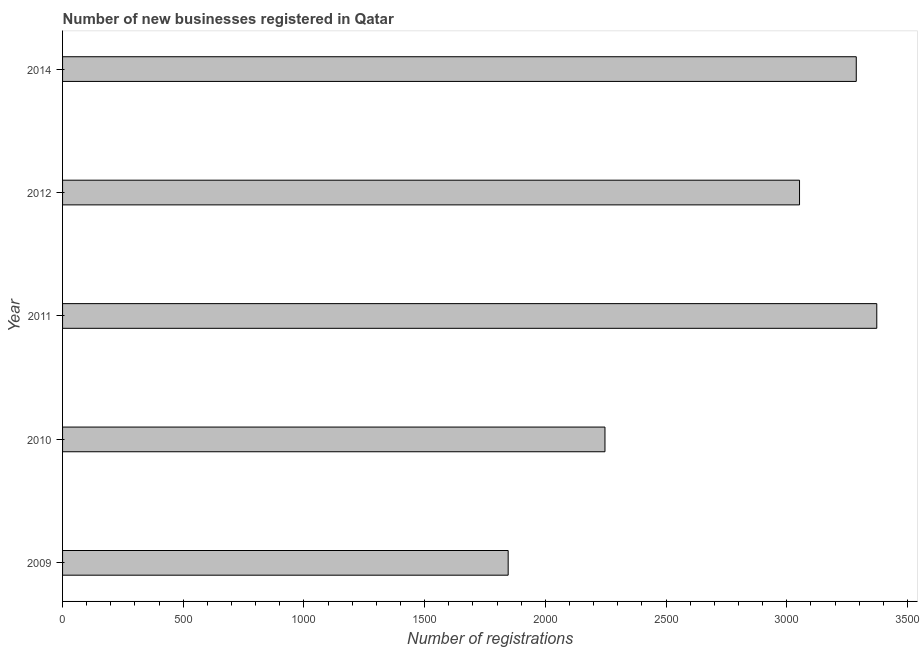Does the graph contain grids?
Provide a short and direct response. No. What is the title of the graph?
Keep it short and to the point. Number of new businesses registered in Qatar. What is the label or title of the X-axis?
Your answer should be very brief. Number of registrations. What is the number of new business registrations in 2014?
Your answer should be very brief. 3288. Across all years, what is the maximum number of new business registrations?
Provide a succinct answer. 3373. Across all years, what is the minimum number of new business registrations?
Ensure brevity in your answer.  1846. What is the sum of the number of new business registrations?
Your response must be concise. 1.38e+04. What is the difference between the number of new business registrations in 2010 and 2012?
Offer a terse response. -806. What is the average number of new business registrations per year?
Ensure brevity in your answer.  2761. What is the median number of new business registrations?
Your answer should be compact. 3053. In how many years, is the number of new business registrations greater than 1900 ?
Keep it short and to the point. 4. What is the difference between the highest and the second highest number of new business registrations?
Your response must be concise. 85. What is the difference between the highest and the lowest number of new business registrations?
Make the answer very short. 1527. How many bars are there?
Provide a succinct answer. 5. Are all the bars in the graph horizontal?
Make the answer very short. Yes. What is the difference between two consecutive major ticks on the X-axis?
Make the answer very short. 500. Are the values on the major ticks of X-axis written in scientific E-notation?
Offer a very short reply. No. What is the Number of registrations in 2009?
Ensure brevity in your answer.  1846. What is the Number of registrations of 2010?
Provide a succinct answer. 2247. What is the Number of registrations in 2011?
Make the answer very short. 3373. What is the Number of registrations in 2012?
Your answer should be very brief. 3053. What is the Number of registrations of 2014?
Your answer should be very brief. 3288. What is the difference between the Number of registrations in 2009 and 2010?
Offer a terse response. -401. What is the difference between the Number of registrations in 2009 and 2011?
Your answer should be compact. -1527. What is the difference between the Number of registrations in 2009 and 2012?
Your answer should be very brief. -1207. What is the difference between the Number of registrations in 2009 and 2014?
Offer a very short reply. -1442. What is the difference between the Number of registrations in 2010 and 2011?
Offer a terse response. -1126. What is the difference between the Number of registrations in 2010 and 2012?
Make the answer very short. -806. What is the difference between the Number of registrations in 2010 and 2014?
Offer a terse response. -1041. What is the difference between the Number of registrations in 2011 and 2012?
Provide a succinct answer. 320. What is the difference between the Number of registrations in 2012 and 2014?
Offer a very short reply. -235. What is the ratio of the Number of registrations in 2009 to that in 2010?
Provide a succinct answer. 0.82. What is the ratio of the Number of registrations in 2009 to that in 2011?
Make the answer very short. 0.55. What is the ratio of the Number of registrations in 2009 to that in 2012?
Your answer should be very brief. 0.6. What is the ratio of the Number of registrations in 2009 to that in 2014?
Keep it short and to the point. 0.56. What is the ratio of the Number of registrations in 2010 to that in 2011?
Give a very brief answer. 0.67. What is the ratio of the Number of registrations in 2010 to that in 2012?
Offer a terse response. 0.74. What is the ratio of the Number of registrations in 2010 to that in 2014?
Your response must be concise. 0.68. What is the ratio of the Number of registrations in 2011 to that in 2012?
Your answer should be compact. 1.1. What is the ratio of the Number of registrations in 2012 to that in 2014?
Your response must be concise. 0.93. 